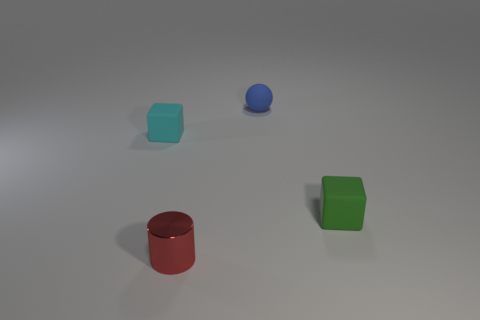Subtract all cyan cubes. How many cubes are left? 1 Add 4 gray spheres. How many objects exist? 8 Subtract 1 cylinders. How many cylinders are left? 0 Subtract all balls. How many objects are left? 3 Subtract all yellow cubes. Subtract all purple cylinders. How many cubes are left? 2 Subtract all big purple rubber spheres. Subtract all green rubber things. How many objects are left? 3 Add 4 green objects. How many green objects are left? 5 Add 2 matte balls. How many matte balls exist? 3 Subtract 0 cyan balls. How many objects are left? 4 